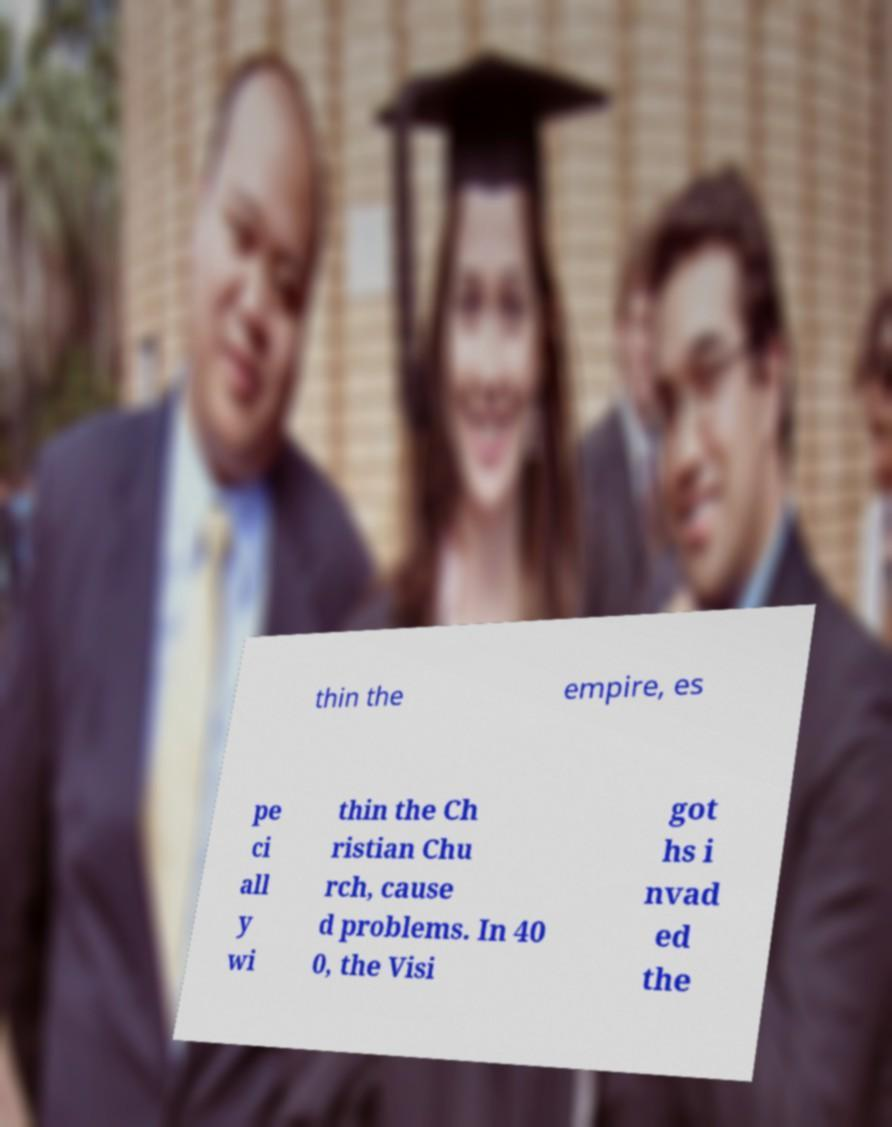Could you extract and type out the text from this image? thin the empire, es pe ci all y wi thin the Ch ristian Chu rch, cause d problems. In 40 0, the Visi got hs i nvad ed the 